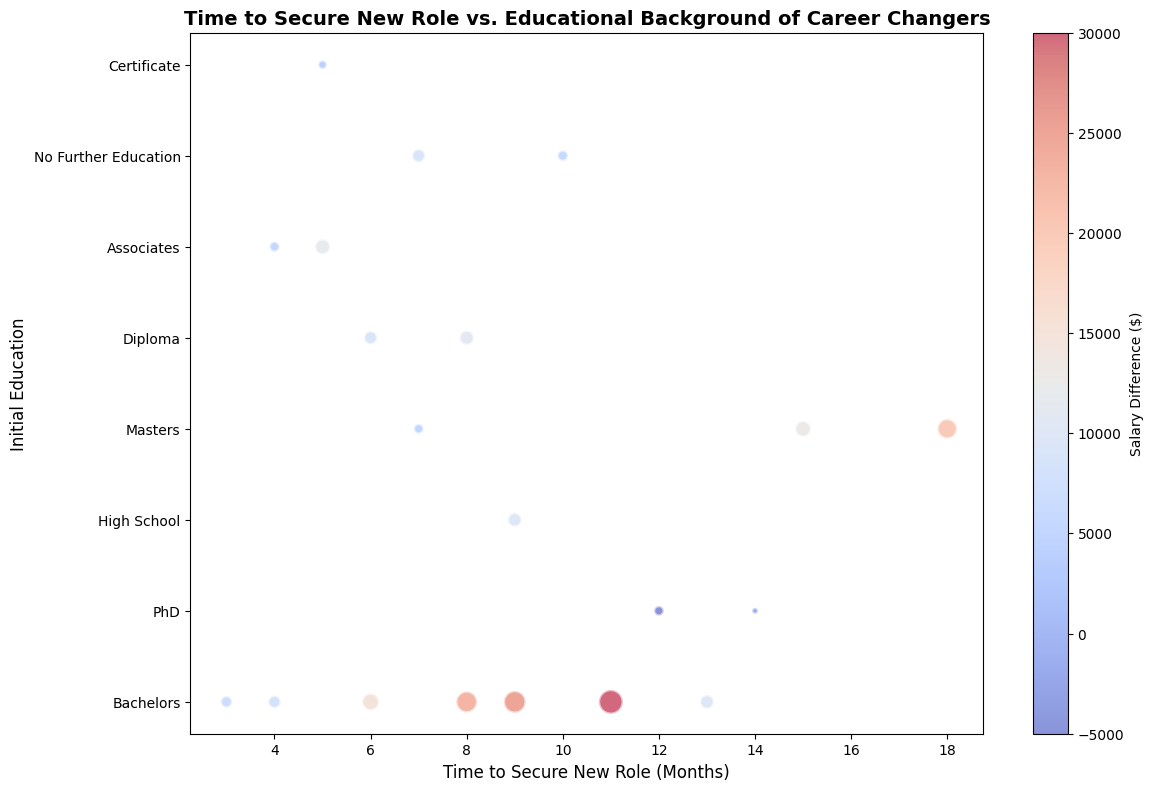Which initial education background has the largest bubble? Identify the initial education background based on the size of the bubble. The largest bubble represents the highest salary difference.
Answer: Bachelors Which group secured a new role the fastest? Look for the shortest time on the x-axis. The shortest time to secure a new role implies the fastest transition.
Answer: Bachelors, Certificate What is the average time to secure a new role for individuals with a PhD? Find the points with PhD as the initial education and compute the average time to secure a new role. The relevant time periods are 12 and 14 months. \((12 + 14) / 2 = 13\)
Answer: 13 months Which education background upgrade (initial vs. new) saw the highest salary difference? Look at the color intensity and size of the bubble. The highest salary difference will have the largest bubble and the most intense color.
Answer: Bachelors to MBA Which transition period has the widest range of salary differences? Observe the range of colors for bubbles within each time period (x-value). The widest range of colors indicates the most variation in salary differences.
Answer: 8 months For those who transitioned from Bachelors, what is the average salary difference? Identify the bubbles for initial education "Bachelors," sum up their corresponding salary differences, and divide by the number of such bubbles. The relevant salary differences are: \( 15000, 8000, 23000, 25000, 30000, 10000, 7000 \) \((15000 + 8000 + 23000 + 25000 + 30000 + 10000 + 7000)/7 = 16857.14\)
Answer: $16,857.14 Does a longer time to secure a role correlate with higher salary differences? Compare the color and sizes of bubbles on the right side of the x-axis with those on the left side. Investigate if larger and more intensely colored bubbles appear more frequently with longer times.
Answer: Not necessarily, the relationship is not clear Which education transition has the least negative salary difference? Look for the smallest bubble with the least dark blue tone. Negative salary differences are indicated by negative values.
Answer: PhD to No Further Education 